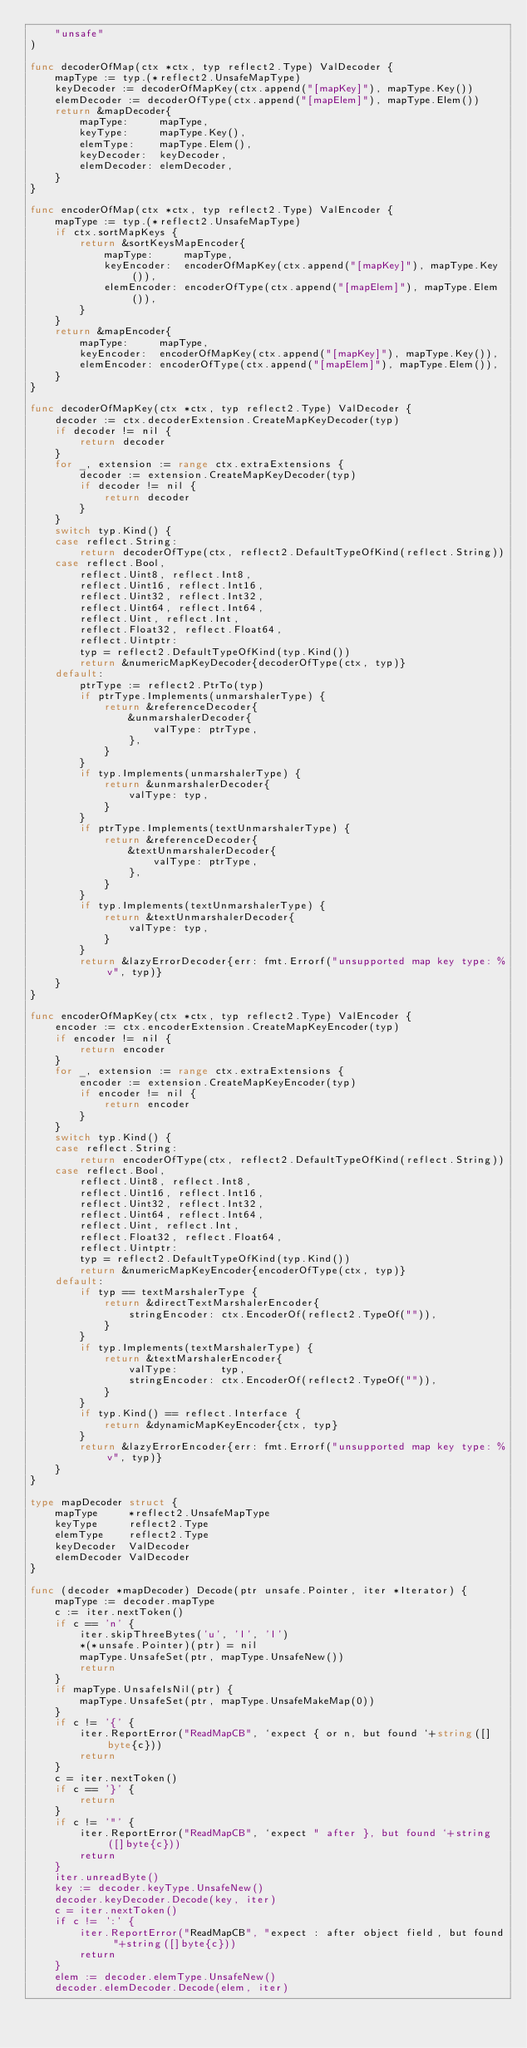Convert code to text. <code><loc_0><loc_0><loc_500><loc_500><_Go_>	"unsafe"
)

func decoderOfMap(ctx *ctx, typ reflect2.Type) ValDecoder {
	mapType := typ.(*reflect2.UnsafeMapType)
	keyDecoder := decoderOfMapKey(ctx.append("[mapKey]"), mapType.Key())
	elemDecoder := decoderOfType(ctx.append("[mapElem]"), mapType.Elem())
	return &mapDecoder{
		mapType:     mapType,
		keyType:     mapType.Key(),
		elemType:    mapType.Elem(),
		keyDecoder:  keyDecoder,
		elemDecoder: elemDecoder,
	}
}

func encoderOfMap(ctx *ctx, typ reflect2.Type) ValEncoder {
	mapType := typ.(*reflect2.UnsafeMapType)
	if ctx.sortMapKeys {
		return &sortKeysMapEncoder{
			mapType:     mapType,
			keyEncoder:  encoderOfMapKey(ctx.append("[mapKey]"), mapType.Key()),
			elemEncoder: encoderOfType(ctx.append("[mapElem]"), mapType.Elem()),
		}
	}
	return &mapEncoder{
		mapType:     mapType,
		keyEncoder:  encoderOfMapKey(ctx.append("[mapKey]"), mapType.Key()),
		elemEncoder: encoderOfType(ctx.append("[mapElem]"), mapType.Elem()),
	}
}

func decoderOfMapKey(ctx *ctx, typ reflect2.Type) ValDecoder {
	decoder := ctx.decoderExtension.CreateMapKeyDecoder(typ)
	if decoder != nil {
		return decoder
	}
	for _, extension := range ctx.extraExtensions {
		decoder := extension.CreateMapKeyDecoder(typ)
		if decoder != nil {
			return decoder
		}
	}
	switch typ.Kind() {
	case reflect.String:
		return decoderOfType(ctx, reflect2.DefaultTypeOfKind(reflect.String))
	case reflect.Bool,
		reflect.Uint8, reflect.Int8,
		reflect.Uint16, reflect.Int16,
		reflect.Uint32, reflect.Int32,
		reflect.Uint64, reflect.Int64,
		reflect.Uint, reflect.Int,
		reflect.Float32, reflect.Float64,
		reflect.Uintptr:
		typ = reflect2.DefaultTypeOfKind(typ.Kind())
		return &numericMapKeyDecoder{decoderOfType(ctx, typ)}
	default:
		ptrType := reflect2.PtrTo(typ)
		if ptrType.Implements(unmarshalerType) {
			return &referenceDecoder{
				&unmarshalerDecoder{
					valType: ptrType,
				},
			}
		}
		if typ.Implements(unmarshalerType) {
			return &unmarshalerDecoder{
				valType: typ,
			}
		}
		if ptrType.Implements(textUnmarshalerType) {
			return &referenceDecoder{
				&textUnmarshalerDecoder{
					valType: ptrType,
				},
			}
		}
		if typ.Implements(textUnmarshalerType) {
			return &textUnmarshalerDecoder{
				valType: typ,
			}
		}
		return &lazyErrorDecoder{err: fmt.Errorf("unsupported map key type: %v", typ)}
	}
}

func encoderOfMapKey(ctx *ctx, typ reflect2.Type) ValEncoder {
	encoder := ctx.encoderExtension.CreateMapKeyEncoder(typ)
	if encoder != nil {
		return encoder
	}
	for _, extension := range ctx.extraExtensions {
		encoder := extension.CreateMapKeyEncoder(typ)
		if encoder != nil {
			return encoder
		}
	}
	switch typ.Kind() {
	case reflect.String:
		return encoderOfType(ctx, reflect2.DefaultTypeOfKind(reflect.String))
	case reflect.Bool,
		reflect.Uint8, reflect.Int8,
		reflect.Uint16, reflect.Int16,
		reflect.Uint32, reflect.Int32,
		reflect.Uint64, reflect.Int64,
		reflect.Uint, reflect.Int,
		reflect.Float32, reflect.Float64,
		reflect.Uintptr:
		typ = reflect2.DefaultTypeOfKind(typ.Kind())
		return &numericMapKeyEncoder{encoderOfType(ctx, typ)}
	default:
		if typ == textMarshalerType {
			return &directTextMarshalerEncoder{
				stringEncoder: ctx.EncoderOf(reflect2.TypeOf("")),
			}
		}
		if typ.Implements(textMarshalerType) {
			return &textMarshalerEncoder{
				valType:       typ,
				stringEncoder: ctx.EncoderOf(reflect2.TypeOf("")),
			}
		}
		if typ.Kind() == reflect.Interface {
			return &dynamicMapKeyEncoder{ctx, typ}
		}
		return &lazyErrorEncoder{err: fmt.Errorf("unsupported map key type: %v", typ)}
	}
}

type mapDecoder struct {
	mapType     *reflect2.UnsafeMapType
	keyType     reflect2.Type
	elemType    reflect2.Type
	keyDecoder  ValDecoder
	elemDecoder ValDecoder
}

func (decoder *mapDecoder) Decode(ptr unsafe.Pointer, iter *Iterator) {
	mapType := decoder.mapType
	c := iter.nextToken()
	if c == 'n' {
		iter.skipThreeBytes('u', 'l', 'l')
		*(*unsafe.Pointer)(ptr) = nil
		mapType.UnsafeSet(ptr, mapType.UnsafeNew())
		return
	}
	if mapType.UnsafeIsNil(ptr) {
		mapType.UnsafeSet(ptr, mapType.UnsafeMakeMap(0))
	}
	if c != '{' {
		iter.ReportError("ReadMapCB", `expect { or n, but found `+string([]byte{c}))
		return
	}
	c = iter.nextToken()
	if c == '}' {
		return
	}
	if c != '"' {
		iter.ReportError("ReadMapCB", `expect " after }, but found `+string([]byte{c}))
		return
	}
	iter.unreadByte()
	key := decoder.keyType.UnsafeNew()
	decoder.keyDecoder.Decode(key, iter)
	c = iter.nextToken()
	if c != ':' {
		iter.ReportError("ReadMapCB", "expect : after object field, but found "+string([]byte{c}))
		return
	}
	elem := decoder.elemType.UnsafeNew()
	decoder.elemDecoder.Decode(elem, iter)</code> 